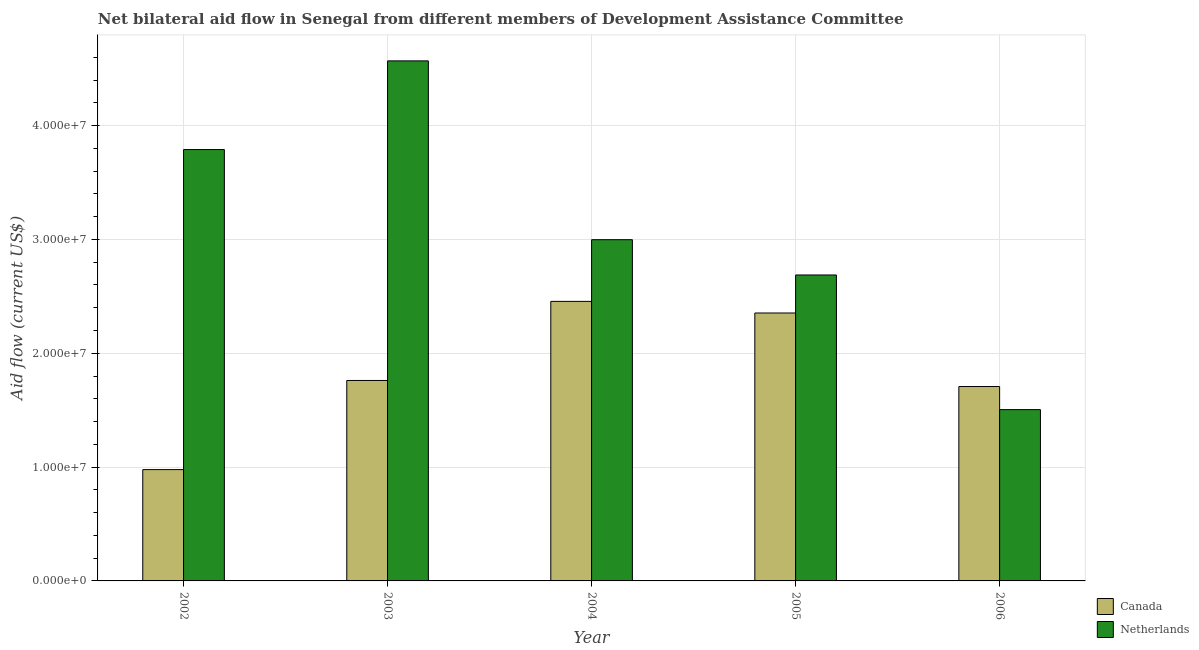How many groups of bars are there?
Provide a short and direct response. 5. How many bars are there on the 4th tick from the left?
Your answer should be very brief. 2. What is the label of the 4th group of bars from the left?
Ensure brevity in your answer.  2005. What is the amount of aid given by canada in 2005?
Offer a terse response. 2.35e+07. Across all years, what is the maximum amount of aid given by canada?
Provide a succinct answer. 2.46e+07. Across all years, what is the minimum amount of aid given by canada?
Give a very brief answer. 9.78e+06. What is the total amount of aid given by canada in the graph?
Your answer should be compact. 9.26e+07. What is the difference between the amount of aid given by netherlands in 2003 and that in 2004?
Offer a very short reply. 1.57e+07. What is the difference between the amount of aid given by canada in 2006 and the amount of aid given by netherlands in 2004?
Offer a very short reply. -7.48e+06. What is the average amount of aid given by netherlands per year?
Offer a terse response. 3.11e+07. What is the ratio of the amount of aid given by netherlands in 2002 to that in 2005?
Your response must be concise. 1.41. Is the amount of aid given by canada in 2002 less than that in 2005?
Give a very brief answer. Yes. What is the difference between the highest and the second highest amount of aid given by canada?
Offer a very short reply. 1.02e+06. What is the difference between the highest and the lowest amount of aid given by canada?
Your response must be concise. 1.48e+07. Is the sum of the amount of aid given by canada in 2003 and 2005 greater than the maximum amount of aid given by netherlands across all years?
Offer a terse response. Yes. What does the 1st bar from the right in 2002 represents?
Give a very brief answer. Netherlands. How many bars are there?
Offer a terse response. 10. Are all the bars in the graph horizontal?
Give a very brief answer. No. What is the difference between two consecutive major ticks on the Y-axis?
Ensure brevity in your answer.  1.00e+07. Are the values on the major ticks of Y-axis written in scientific E-notation?
Ensure brevity in your answer.  Yes. How many legend labels are there?
Ensure brevity in your answer.  2. What is the title of the graph?
Offer a terse response. Net bilateral aid flow in Senegal from different members of Development Assistance Committee. Does "Nonresident" appear as one of the legend labels in the graph?
Keep it short and to the point. No. What is the Aid flow (current US$) of Canada in 2002?
Your answer should be very brief. 9.78e+06. What is the Aid flow (current US$) in Netherlands in 2002?
Offer a very short reply. 3.79e+07. What is the Aid flow (current US$) in Canada in 2003?
Ensure brevity in your answer.  1.76e+07. What is the Aid flow (current US$) in Netherlands in 2003?
Provide a short and direct response. 4.57e+07. What is the Aid flow (current US$) of Canada in 2004?
Your answer should be very brief. 2.46e+07. What is the Aid flow (current US$) in Netherlands in 2004?
Offer a very short reply. 3.00e+07. What is the Aid flow (current US$) in Canada in 2005?
Keep it short and to the point. 2.35e+07. What is the Aid flow (current US$) in Netherlands in 2005?
Your answer should be very brief. 2.69e+07. What is the Aid flow (current US$) in Canada in 2006?
Ensure brevity in your answer.  1.71e+07. What is the Aid flow (current US$) in Netherlands in 2006?
Offer a terse response. 1.50e+07. Across all years, what is the maximum Aid flow (current US$) in Canada?
Provide a succinct answer. 2.46e+07. Across all years, what is the maximum Aid flow (current US$) in Netherlands?
Your response must be concise. 4.57e+07. Across all years, what is the minimum Aid flow (current US$) in Canada?
Your response must be concise. 9.78e+06. Across all years, what is the minimum Aid flow (current US$) of Netherlands?
Your answer should be very brief. 1.50e+07. What is the total Aid flow (current US$) of Canada in the graph?
Provide a short and direct response. 9.26e+07. What is the total Aid flow (current US$) of Netherlands in the graph?
Give a very brief answer. 1.56e+08. What is the difference between the Aid flow (current US$) in Canada in 2002 and that in 2003?
Ensure brevity in your answer.  -7.83e+06. What is the difference between the Aid flow (current US$) in Netherlands in 2002 and that in 2003?
Your response must be concise. -7.79e+06. What is the difference between the Aid flow (current US$) in Canada in 2002 and that in 2004?
Offer a terse response. -1.48e+07. What is the difference between the Aid flow (current US$) in Netherlands in 2002 and that in 2004?
Make the answer very short. 7.92e+06. What is the difference between the Aid flow (current US$) of Canada in 2002 and that in 2005?
Ensure brevity in your answer.  -1.38e+07. What is the difference between the Aid flow (current US$) in Netherlands in 2002 and that in 2005?
Keep it short and to the point. 1.10e+07. What is the difference between the Aid flow (current US$) in Canada in 2002 and that in 2006?
Your response must be concise. -7.30e+06. What is the difference between the Aid flow (current US$) in Netherlands in 2002 and that in 2006?
Offer a very short reply. 2.28e+07. What is the difference between the Aid flow (current US$) of Canada in 2003 and that in 2004?
Your answer should be very brief. -6.95e+06. What is the difference between the Aid flow (current US$) of Netherlands in 2003 and that in 2004?
Your answer should be very brief. 1.57e+07. What is the difference between the Aid flow (current US$) of Canada in 2003 and that in 2005?
Offer a terse response. -5.93e+06. What is the difference between the Aid flow (current US$) in Netherlands in 2003 and that in 2005?
Your response must be concise. 1.88e+07. What is the difference between the Aid flow (current US$) in Canada in 2003 and that in 2006?
Make the answer very short. 5.30e+05. What is the difference between the Aid flow (current US$) in Netherlands in 2003 and that in 2006?
Provide a succinct answer. 3.06e+07. What is the difference between the Aid flow (current US$) in Canada in 2004 and that in 2005?
Provide a short and direct response. 1.02e+06. What is the difference between the Aid flow (current US$) in Netherlands in 2004 and that in 2005?
Your answer should be very brief. 3.10e+06. What is the difference between the Aid flow (current US$) of Canada in 2004 and that in 2006?
Ensure brevity in your answer.  7.48e+06. What is the difference between the Aid flow (current US$) of Netherlands in 2004 and that in 2006?
Offer a very short reply. 1.49e+07. What is the difference between the Aid flow (current US$) of Canada in 2005 and that in 2006?
Your answer should be compact. 6.46e+06. What is the difference between the Aid flow (current US$) of Netherlands in 2005 and that in 2006?
Provide a short and direct response. 1.18e+07. What is the difference between the Aid flow (current US$) of Canada in 2002 and the Aid flow (current US$) of Netherlands in 2003?
Offer a terse response. -3.59e+07. What is the difference between the Aid flow (current US$) of Canada in 2002 and the Aid flow (current US$) of Netherlands in 2004?
Your answer should be compact. -2.02e+07. What is the difference between the Aid flow (current US$) in Canada in 2002 and the Aid flow (current US$) in Netherlands in 2005?
Your answer should be compact. -1.71e+07. What is the difference between the Aid flow (current US$) of Canada in 2002 and the Aid flow (current US$) of Netherlands in 2006?
Offer a very short reply. -5.27e+06. What is the difference between the Aid flow (current US$) of Canada in 2003 and the Aid flow (current US$) of Netherlands in 2004?
Offer a terse response. -1.24e+07. What is the difference between the Aid flow (current US$) of Canada in 2003 and the Aid flow (current US$) of Netherlands in 2005?
Offer a terse response. -9.27e+06. What is the difference between the Aid flow (current US$) in Canada in 2003 and the Aid flow (current US$) in Netherlands in 2006?
Your response must be concise. 2.56e+06. What is the difference between the Aid flow (current US$) in Canada in 2004 and the Aid flow (current US$) in Netherlands in 2005?
Provide a succinct answer. -2.32e+06. What is the difference between the Aid flow (current US$) of Canada in 2004 and the Aid flow (current US$) of Netherlands in 2006?
Your response must be concise. 9.51e+06. What is the difference between the Aid flow (current US$) of Canada in 2005 and the Aid flow (current US$) of Netherlands in 2006?
Make the answer very short. 8.49e+06. What is the average Aid flow (current US$) of Canada per year?
Provide a short and direct response. 1.85e+07. What is the average Aid flow (current US$) of Netherlands per year?
Offer a very short reply. 3.11e+07. In the year 2002, what is the difference between the Aid flow (current US$) in Canada and Aid flow (current US$) in Netherlands?
Provide a succinct answer. -2.81e+07. In the year 2003, what is the difference between the Aid flow (current US$) in Canada and Aid flow (current US$) in Netherlands?
Keep it short and to the point. -2.81e+07. In the year 2004, what is the difference between the Aid flow (current US$) in Canada and Aid flow (current US$) in Netherlands?
Your response must be concise. -5.42e+06. In the year 2005, what is the difference between the Aid flow (current US$) in Canada and Aid flow (current US$) in Netherlands?
Provide a succinct answer. -3.34e+06. In the year 2006, what is the difference between the Aid flow (current US$) of Canada and Aid flow (current US$) of Netherlands?
Your answer should be very brief. 2.03e+06. What is the ratio of the Aid flow (current US$) in Canada in 2002 to that in 2003?
Provide a short and direct response. 0.56. What is the ratio of the Aid flow (current US$) of Netherlands in 2002 to that in 2003?
Your response must be concise. 0.83. What is the ratio of the Aid flow (current US$) in Canada in 2002 to that in 2004?
Offer a very short reply. 0.4. What is the ratio of the Aid flow (current US$) of Netherlands in 2002 to that in 2004?
Keep it short and to the point. 1.26. What is the ratio of the Aid flow (current US$) of Canada in 2002 to that in 2005?
Keep it short and to the point. 0.42. What is the ratio of the Aid flow (current US$) of Netherlands in 2002 to that in 2005?
Ensure brevity in your answer.  1.41. What is the ratio of the Aid flow (current US$) of Canada in 2002 to that in 2006?
Keep it short and to the point. 0.57. What is the ratio of the Aid flow (current US$) of Netherlands in 2002 to that in 2006?
Your answer should be very brief. 2.52. What is the ratio of the Aid flow (current US$) in Canada in 2003 to that in 2004?
Offer a terse response. 0.72. What is the ratio of the Aid flow (current US$) of Netherlands in 2003 to that in 2004?
Ensure brevity in your answer.  1.52. What is the ratio of the Aid flow (current US$) in Canada in 2003 to that in 2005?
Offer a very short reply. 0.75. What is the ratio of the Aid flow (current US$) of Netherlands in 2003 to that in 2005?
Offer a very short reply. 1.7. What is the ratio of the Aid flow (current US$) in Canada in 2003 to that in 2006?
Offer a very short reply. 1.03. What is the ratio of the Aid flow (current US$) of Netherlands in 2003 to that in 2006?
Offer a very short reply. 3.04. What is the ratio of the Aid flow (current US$) in Canada in 2004 to that in 2005?
Your response must be concise. 1.04. What is the ratio of the Aid flow (current US$) of Netherlands in 2004 to that in 2005?
Your answer should be very brief. 1.12. What is the ratio of the Aid flow (current US$) of Canada in 2004 to that in 2006?
Give a very brief answer. 1.44. What is the ratio of the Aid flow (current US$) in Netherlands in 2004 to that in 2006?
Your answer should be compact. 1.99. What is the ratio of the Aid flow (current US$) in Canada in 2005 to that in 2006?
Make the answer very short. 1.38. What is the ratio of the Aid flow (current US$) of Netherlands in 2005 to that in 2006?
Your answer should be compact. 1.79. What is the difference between the highest and the second highest Aid flow (current US$) in Canada?
Keep it short and to the point. 1.02e+06. What is the difference between the highest and the second highest Aid flow (current US$) of Netherlands?
Offer a terse response. 7.79e+06. What is the difference between the highest and the lowest Aid flow (current US$) in Canada?
Give a very brief answer. 1.48e+07. What is the difference between the highest and the lowest Aid flow (current US$) of Netherlands?
Ensure brevity in your answer.  3.06e+07. 